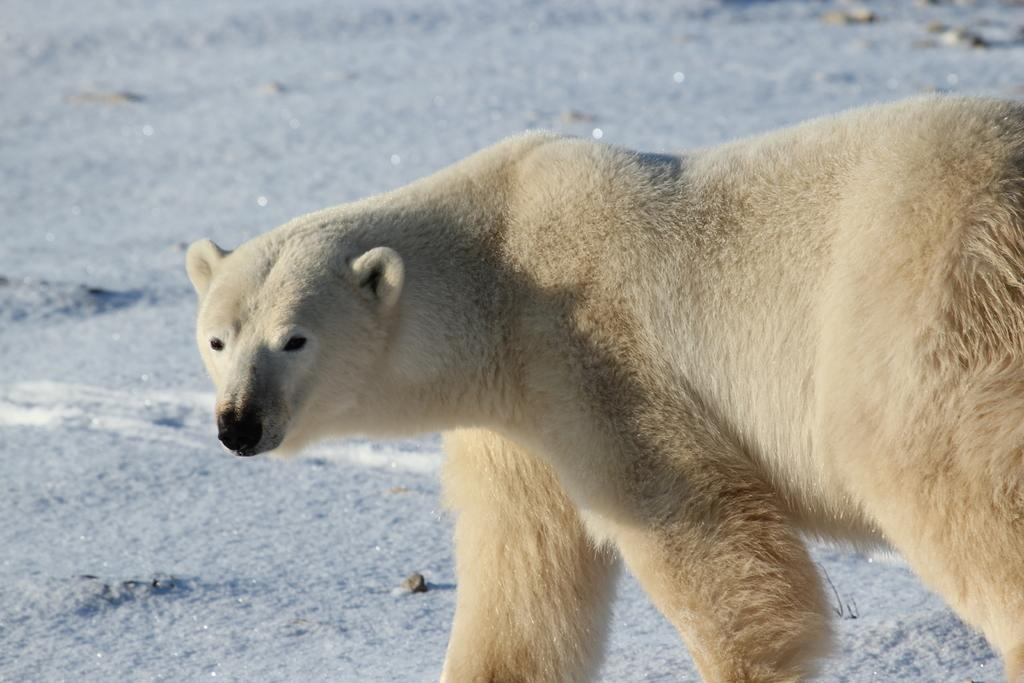What animal is the main subject of the image? There is a polar bear in the image. What is the color of the polar bear? The polar bear is cream-colored. Where is the polar bear positioned in the image? The polar bear is in the front of the image. Can you see the polar bear's pocket in the image? There is no pocket visible on the polar bear in the image. Is the polar bear standing near a sink in the image? There is no sink present in the image. 